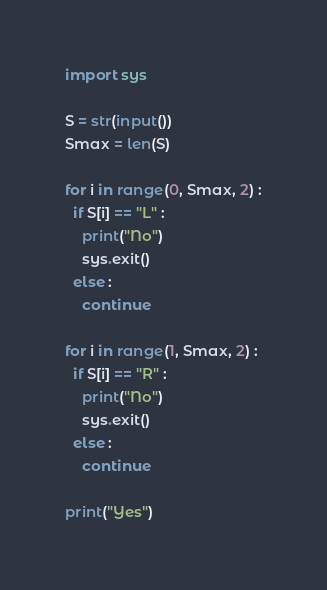Convert code to text. <code><loc_0><loc_0><loc_500><loc_500><_Python_>import sys

S = str(input())
Smax = len(S)

for i in range(0, Smax, 2) :
  if S[i] == "L" :
    print("No")
    sys.exit()
  else :
    continue

for i in range(1, Smax, 2) :
  if S[i] == "R" :
    print("No")
    sys.exit()
  else :
    continue

print("Yes")</code> 